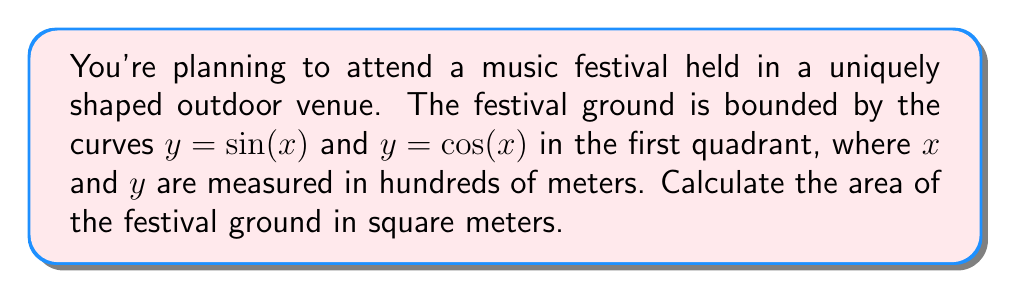Show me your answer to this math problem. To solve this problem, we'll use field integration to calculate the area between the two curves. Here's a step-by-step approach:

1. Identify the region:
   The region is bounded by $y = \sin(x)$ and $y = \cos(x)$ in the first quadrant.

2. Find the intersection points:
   $\sin(x) = \cos(x)$
   $\tan(x) = 1$
   $x = \frac{\pi}{4}$

3. Set up the integral:
   The area is given by:
   $$A = \int_{0}^{\frac{\pi}{4}} [\cos(x) - \sin(x)] dx$$

4. Solve the integral:
   $$\begin{align}
   A &= \int_{0}^{\frac{\pi}{4}} [\cos(x) - \sin(x)] dx \\
   &= [\sin(x) + \cos(x)]_{0}^{\frac{\pi}{4}} \\
   &= (\frac{\sqrt{2}}{2} + \frac{\sqrt{2}}{2}) - (0 + 1) \\
   &= \sqrt{2} - 1
   \end{align}$$

5. Convert to square meters:
   Since $x$ and $y$ are measured in hundreds of meters, we need to multiply our result by $(100 \text{ m})^2 = 10,000 \text{ m}^2$

   $(\sqrt{2} - 1) \times 10,000 \text{ m}^2 = (4142 - 10000) \text{ m}^2 = 4142 \text{ m}^2$
Answer: 4142 m² 